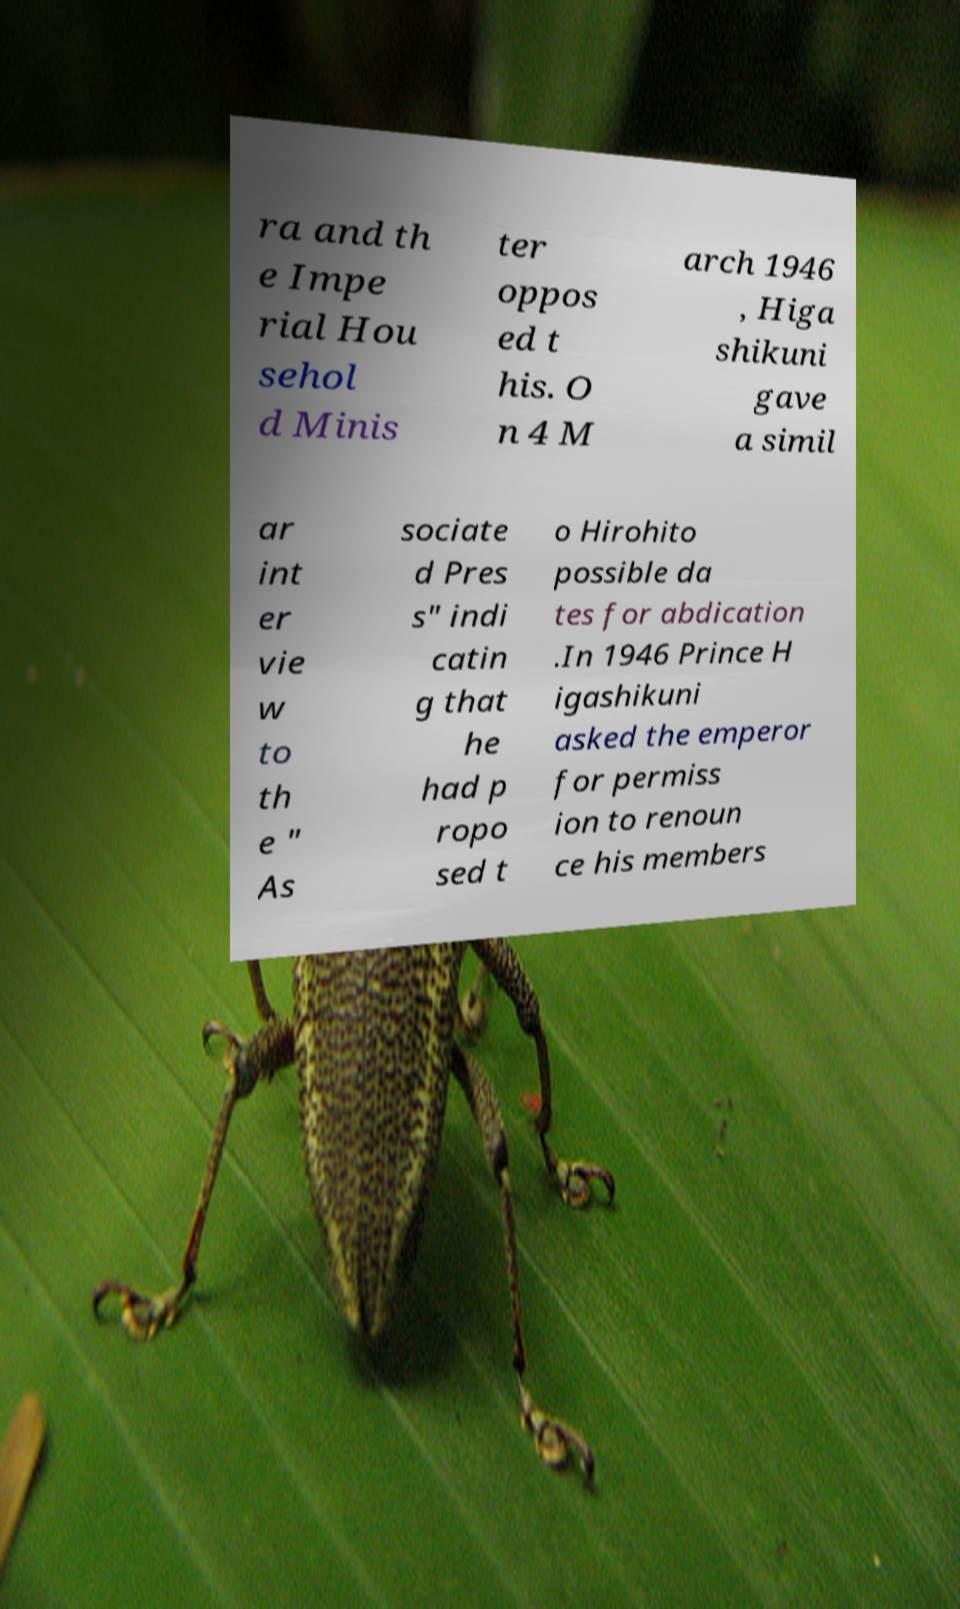What messages or text are displayed in this image? I need them in a readable, typed format. ra and th e Impe rial Hou sehol d Minis ter oppos ed t his. O n 4 M arch 1946 , Higa shikuni gave a simil ar int er vie w to th e " As sociate d Pres s" indi catin g that he had p ropo sed t o Hirohito possible da tes for abdication .In 1946 Prince H igashikuni asked the emperor for permiss ion to renoun ce his members 